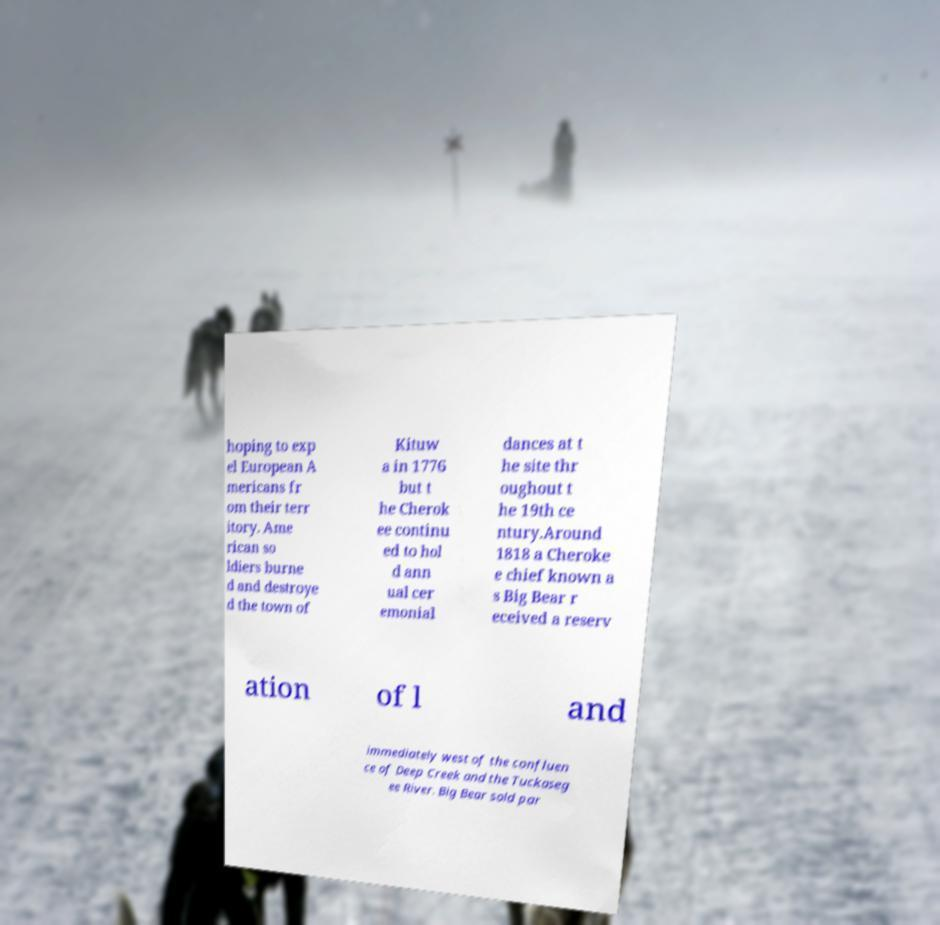There's text embedded in this image that I need extracted. Can you transcribe it verbatim? hoping to exp el European A mericans fr om their terr itory. Ame rican so ldiers burne d and destroye d the town of Kituw a in 1776 but t he Cherok ee continu ed to hol d ann ual cer emonial dances at t he site thr oughout t he 19th ce ntury.Around 1818 a Cheroke e chief known a s Big Bear r eceived a reserv ation of l and immediately west of the confluen ce of Deep Creek and the Tuckaseg ee River. Big Bear sold par 